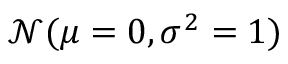<formula> <loc_0><loc_0><loc_500><loc_500>\mathcal { N } ( \mu = 0 , \sigma ^ { 2 } = 1 )</formula> 